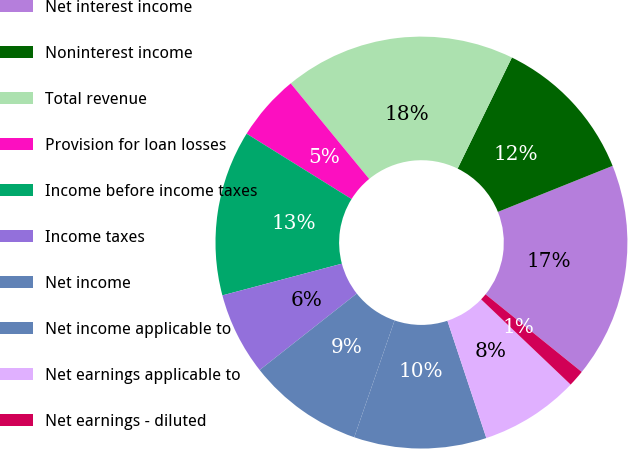Convert chart. <chart><loc_0><loc_0><loc_500><loc_500><pie_chart><fcel>Net interest income<fcel>Noninterest income<fcel>Total revenue<fcel>Provision for loan losses<fcel>Income before income taxes<fcel>Income taxes<fcel>Net income<fcel>Net income applicable to<fcel>Net earnings applicable to<fcel>Net earnings - diluted<nl><fcel>16.88%<fcel>11.69%<fcel>18.18%<fcel>5.19%<fcel>12.99%<fcel>6.49%<fcel>9.09%<fcel>10.39%<fcel>7.79%<fcel>1.3%<nl></chart> 